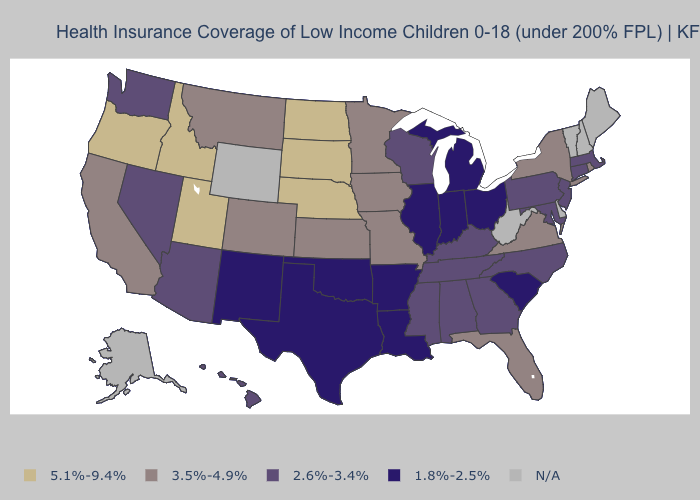What is the value of Alaska?
Give a very brief answer. N/A. Does Nebraska have the highest value in the USA?
Write a very short answer. Yes. What is the highest value in the MidWest ?
Keep it brief. 5.1%-9.4%. Name the states that have a value in the range 1.8%-2.5%?
Write a very short answer. Arkansas, Illinois, Indiana, Louisiana, Michigan, New Mexico, Ohio, Oklahoma, South Carolina, Texas. Name the states that have a value in the range N/A?
Quick response, please. Alaska, Delaware, Maine, New Hampshire, Vermont, West Virginia, Wyoming. Among the states that border Utah , does Idaho have the lowest value?
Short answer required. No. Name the states that have a value in the range N/A?
Concise answer only. Alaska, Delaware, Maine, New Hampshire, Vermont, West Virginia, Wyoming. What is the lowest value in the Northeast?
Answer briefly. 2.6%-3.4%. Does the first symbol in the legend represent the smallest category?
Keep it brief. No. What is the value of Vermont?
Answer briefly. N/A. Name the states that have a value in the range 2.6%-3.4%?
Be succinct. Alabama, Arizona, Connecticut, Georgia, Hawaii, Kentucky, Maryland, Massachusetts, Mississippi, Nevada, New Jersey, North Carolina, Pennsylvania, Tennessee, Washington, Wisconsin. Which states have the lowest value in the USA?
Keep it brief. Arkansas, Illinois, Indiana, Louisiana, Michigan, New Mexico, Ohio, Oklahoma, South Carolina, Texas. Name the states that have a value in the range 2.6%-3.4%?
Answer briefly. Alabama, Arizona, Connecticut, Georgia, Hawaii, Kentucky, Maryland, Massachusetts, Mississippi, Nevada, New Jersey, North Carolina, Pennsylvania, Tennessee, Washington, Wisconsin. What is the value of Wyoming?
Quick response, please. N/A. 